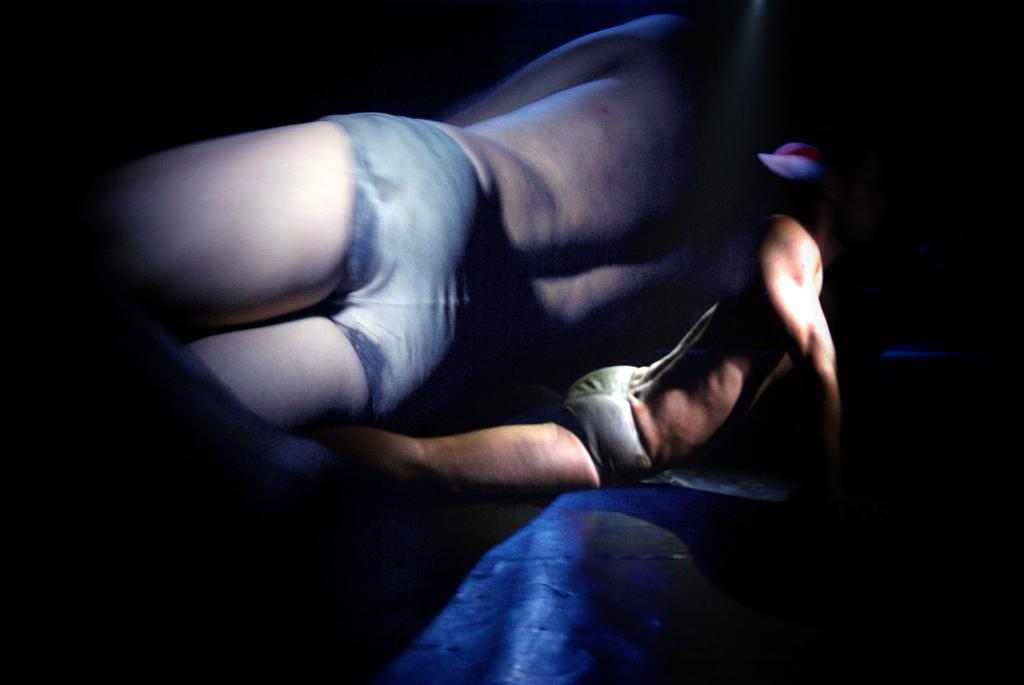What is the main subject of the image? There is a person on the floor in the center of the image. Can you describe the background of the image? There is a picture of a person lying in the background. What type of wave can be seen crashing on the shore in the image? There is no wave or shore present in the image; it features a person on the floor and a picture of a person lying in the background. 